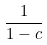<formula> <loc_0><loc_0><loc_500><loc_500>\frac { 1 } { 1 - c }</formula> 